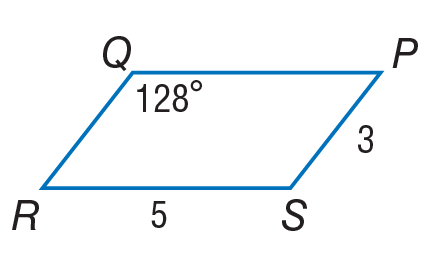Answer the mathemtical geometry problem and directly provide the correct option letter.
Question: Use parallelogram P Q R S to find Q R.
Choices: A: 3 B: 5 C: 15 D: 53 A 